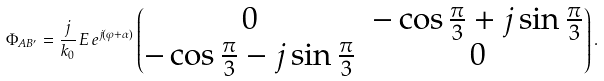<formula> <loc_0><loc_0><loc_500><loc_500>\Phi _ { A B ^ { \prime } } = \frac { j } { k _ { 0 } } \, E \, e ^ { j ( \varphi + \alpha ) } \begin{pmatrix} 0 & - \cos \frac { \pi } { 3 } + j \sin \frac { \pi } { 3 } \\ - \cos \frac { \pi } { 3 } - j \sin \frac { \pi } { 3 } & 0 \\ \end{pmatrix} .</formula> 